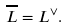<formula> <loc_0><loc_0><loc_500><loc_500>\overline { L } = L ^ { \vee } .</formula> 